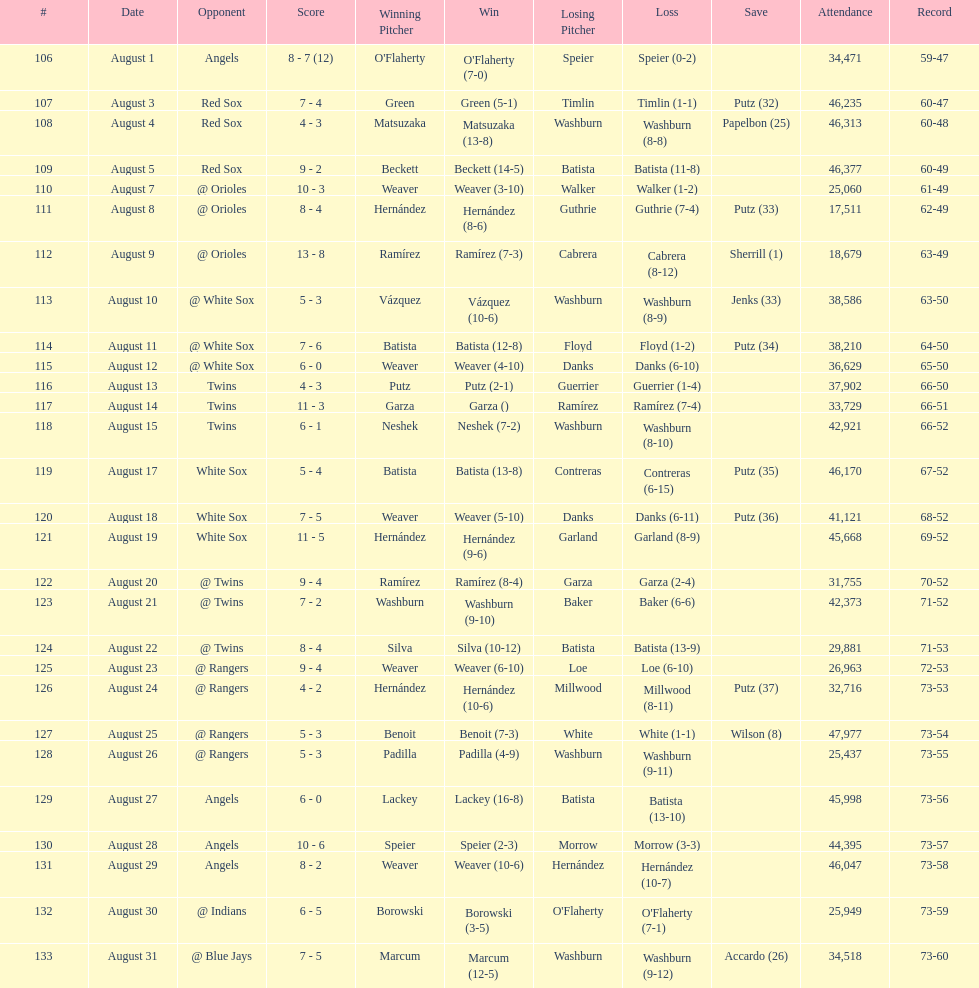Largest run differential 8. 